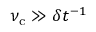<formula> <loc_0><loc_0><loc_500><loc_500>\nu _ { c } \gg \delta t ^ { - 1 }</formula> 